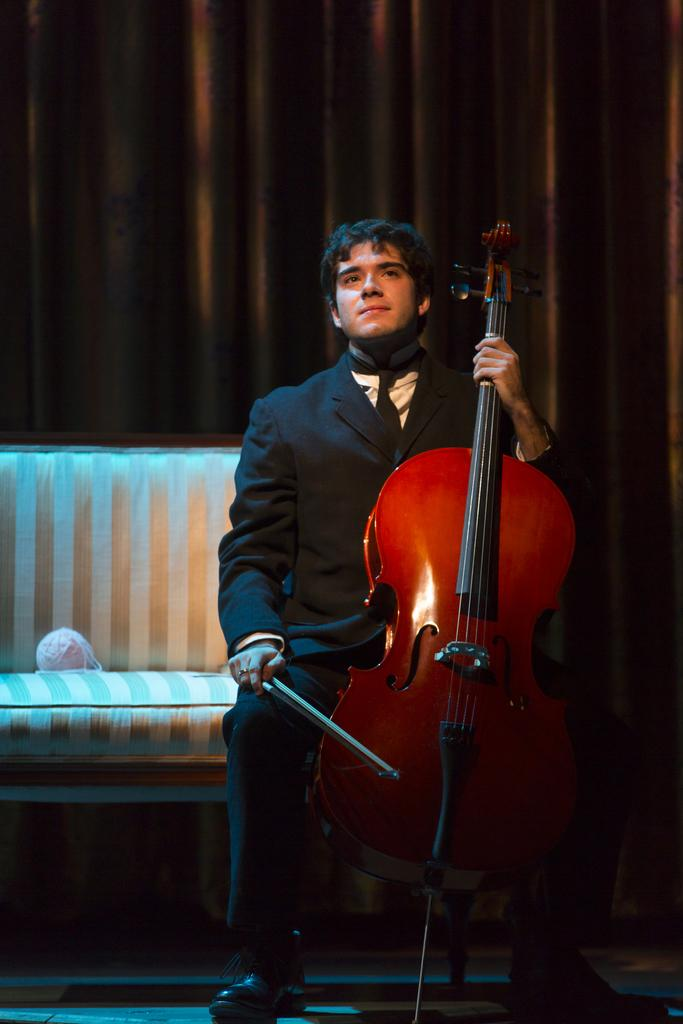What is the main subject of the image? There is a man in the image. What is the man doing in the image? The man is sitting on a chair. What is the man holding in the image? The man is holding a stick and a violin. What can be seen in the background of the image? There is a brown curtain in the background of the image. What is on the chair besides the man? There is an object on the chair. What type of idea can be seen floating in the air in the image? There is no idea floating in the air in the image; it only features a man sitting on a chair holding a stick and a violin, with a brown curtain in the background and an object on the chair. Can you tell me how many stomachs the man has in the image? The image does not show the man's stomach or any indication of the number of stomachs he has. 